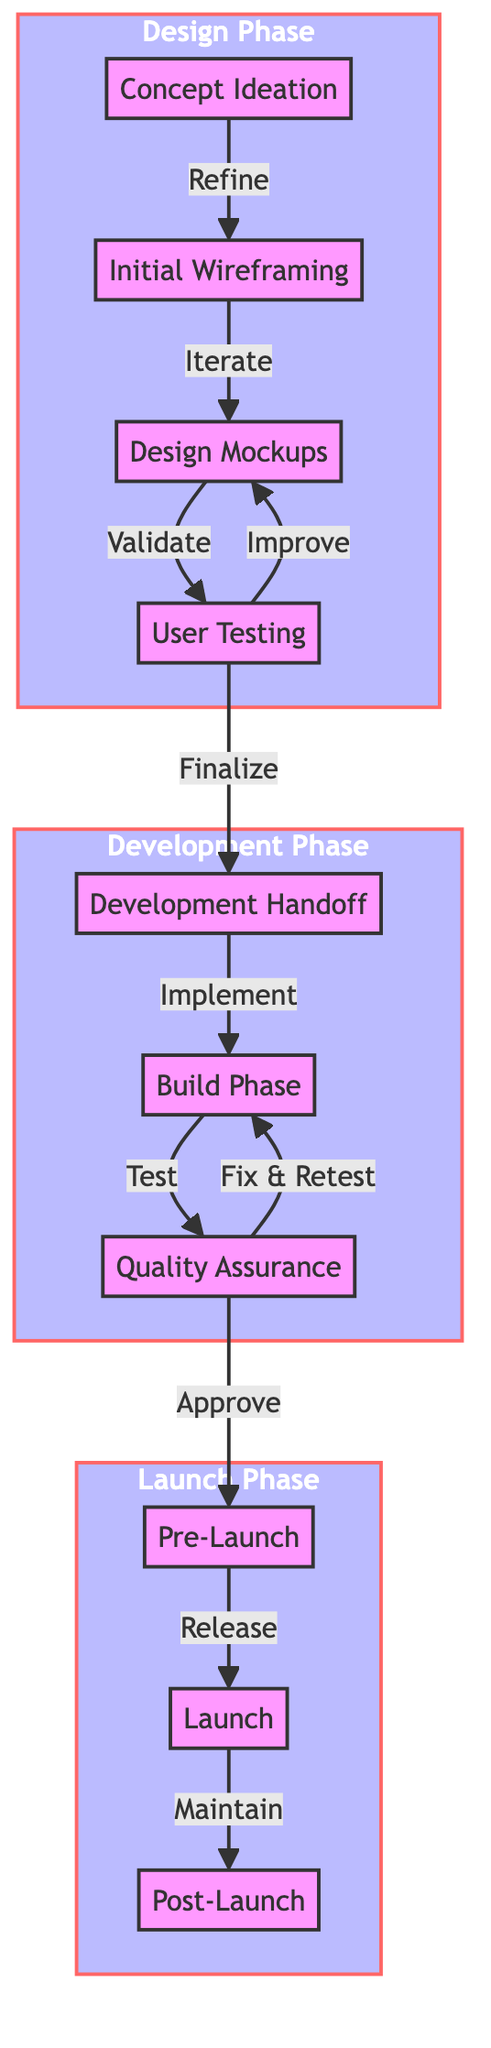What is the first phase in the user journey? The diagram shows that the first phase is labeled as "Concept Ideation" which is the starting point.
Answer: Concept Ideation How many phases are in the entire user journey? By counting the distinct phases indicated in the diagram, we can determine that there are three phases: Design Phase, Development Phase, and Launch Phase.
Answer: 3 Which phase comes after "Design Mockups"? Following the flow, "Design Mockups" is connected to "User Testing," indicating that it comes next in the sequence.
Answer: User Testing In the Launch Phase, what is the final step? The final step in the Launch Phase of the diagram is "Post-Launch," which focuses on ongoing maintenance and updates after the app is launched.
Answer: Post-Launch What relationship is indicated between "Quality Assurance" and "Build Phase"? The diagram specifies that "Quality Assurance" follows "Build Phase" and is reached by the connection labeled "Test," indicating a direct relationship where QA checks the output of the build process.
Answer: Test Which step indicates user feedback collection? The specific step that involves the collection of user feedback is "User Testing," which is directly aimed at gathering response from users about the design.
Answer: User Testing How many connections lead away from "Development Handoff"? Analyzing the diagram reveals that there is one connection leading away from "Development Handoff," pointing to "Build Phase."
Answer: 1 What occurs after the "Pre-Launch" phase? According to the flow, the activity that follows "Pre-Launch" is "Launch," marking the transition from preparation to actual release.
Answer: Launch What is the purpose of the "Post-Launch" phase? The primary focus of the "Post-Launch" phase is ongoing maintenance and updates, ensuring continued user support and feature development.
Answer: Ongoing maintenance and updates 